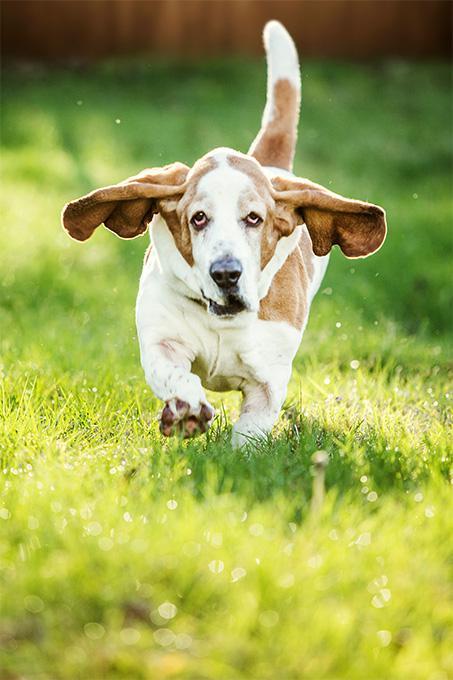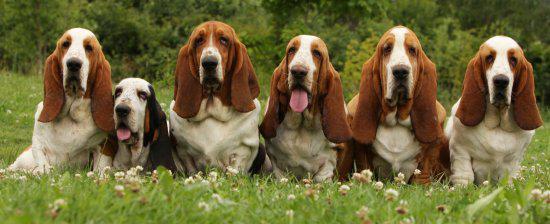The first image is the image on the left, the second image is the image on the right. Examine the images to the left and right. Is the description "One image shows a basset hound bounding toward the camera." accurate? Answer yes or no. Yes. The first image is the image on the left, the second image is the image on the right. For the images shown, is this caption "In one image, a dog with big floppy ears is running." true? Answer yes or no. Yes. 